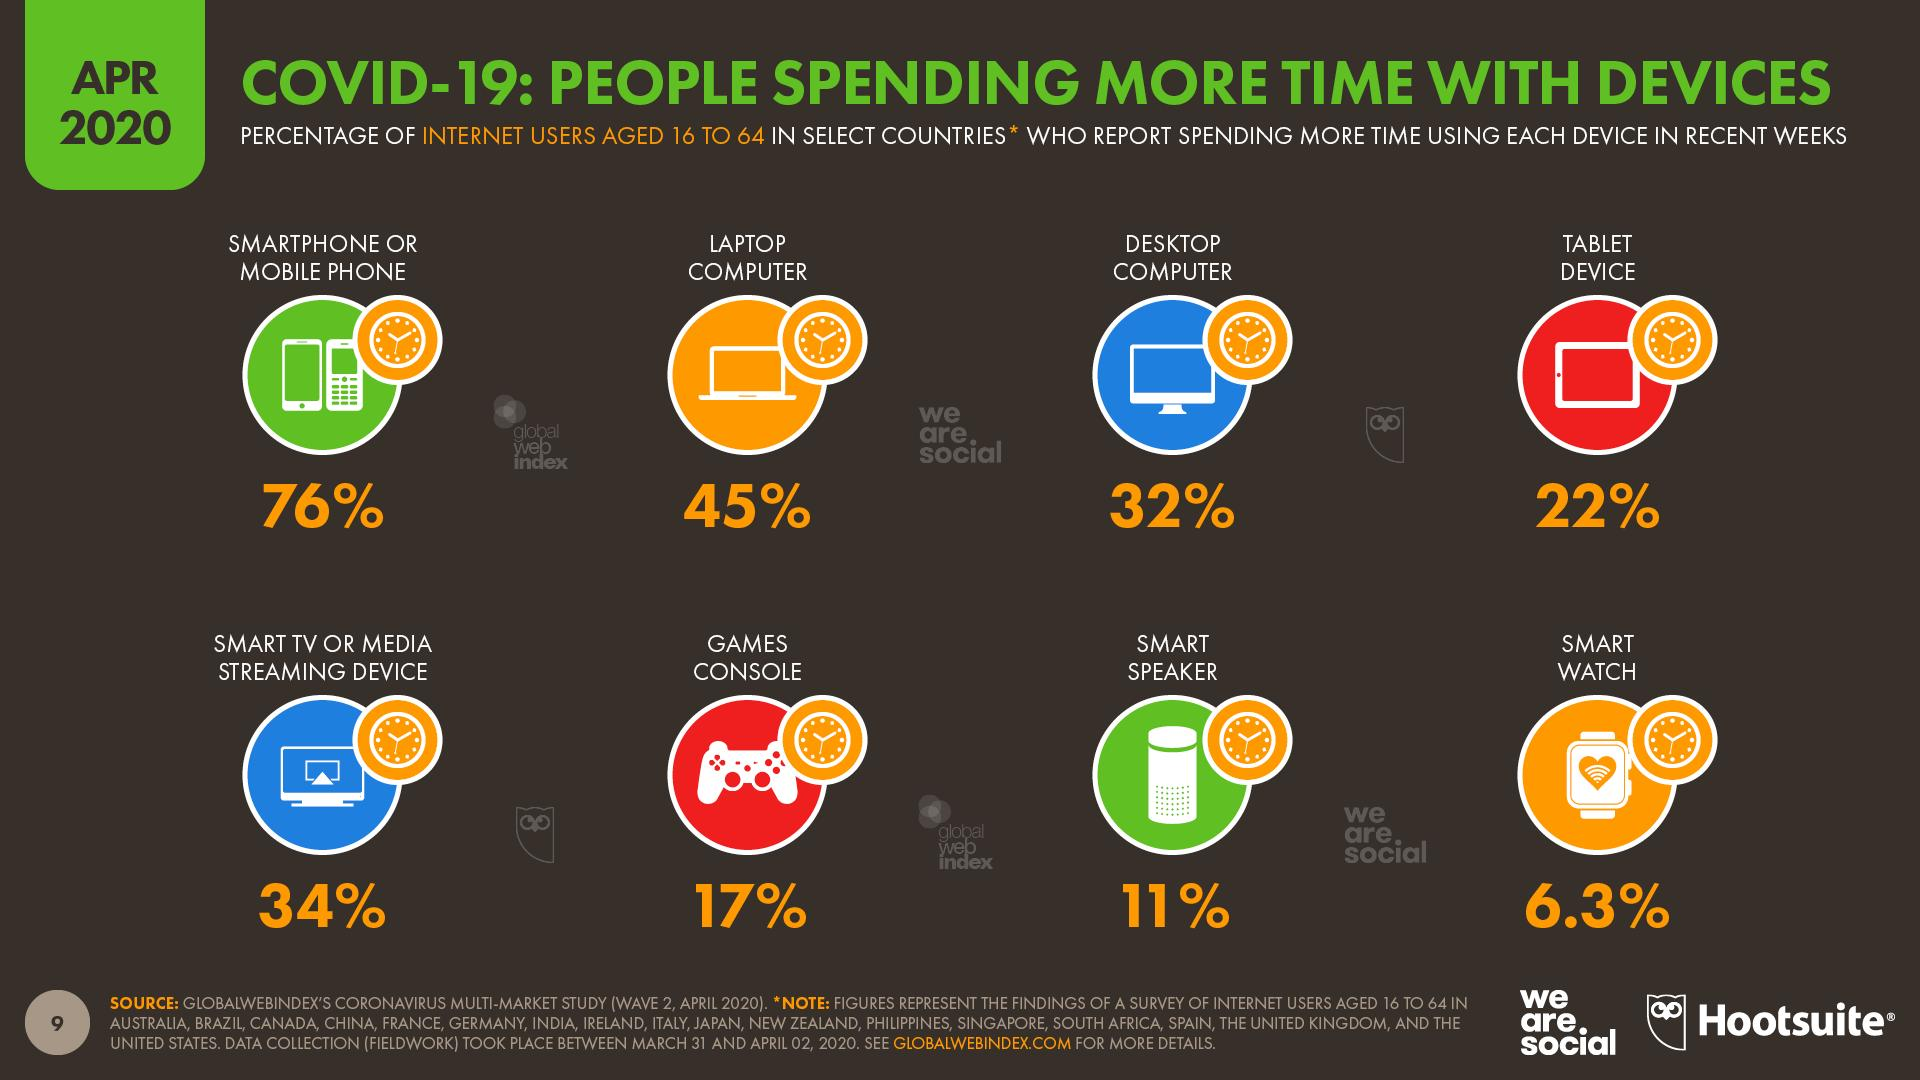Identify some key points in this picture. The second lowest percentage of users use a specific device. According to the report, 45% of people said they spent more time on their laptop computer. The device that is used by 32% of internet users is a desktop computer. According to recent data, smart watches are used by less than 10% of internet users, indicating a potential niche market for companies to target. According to the data, the majority of individuals spent more time on their smartphones rather than their mobile phones. 